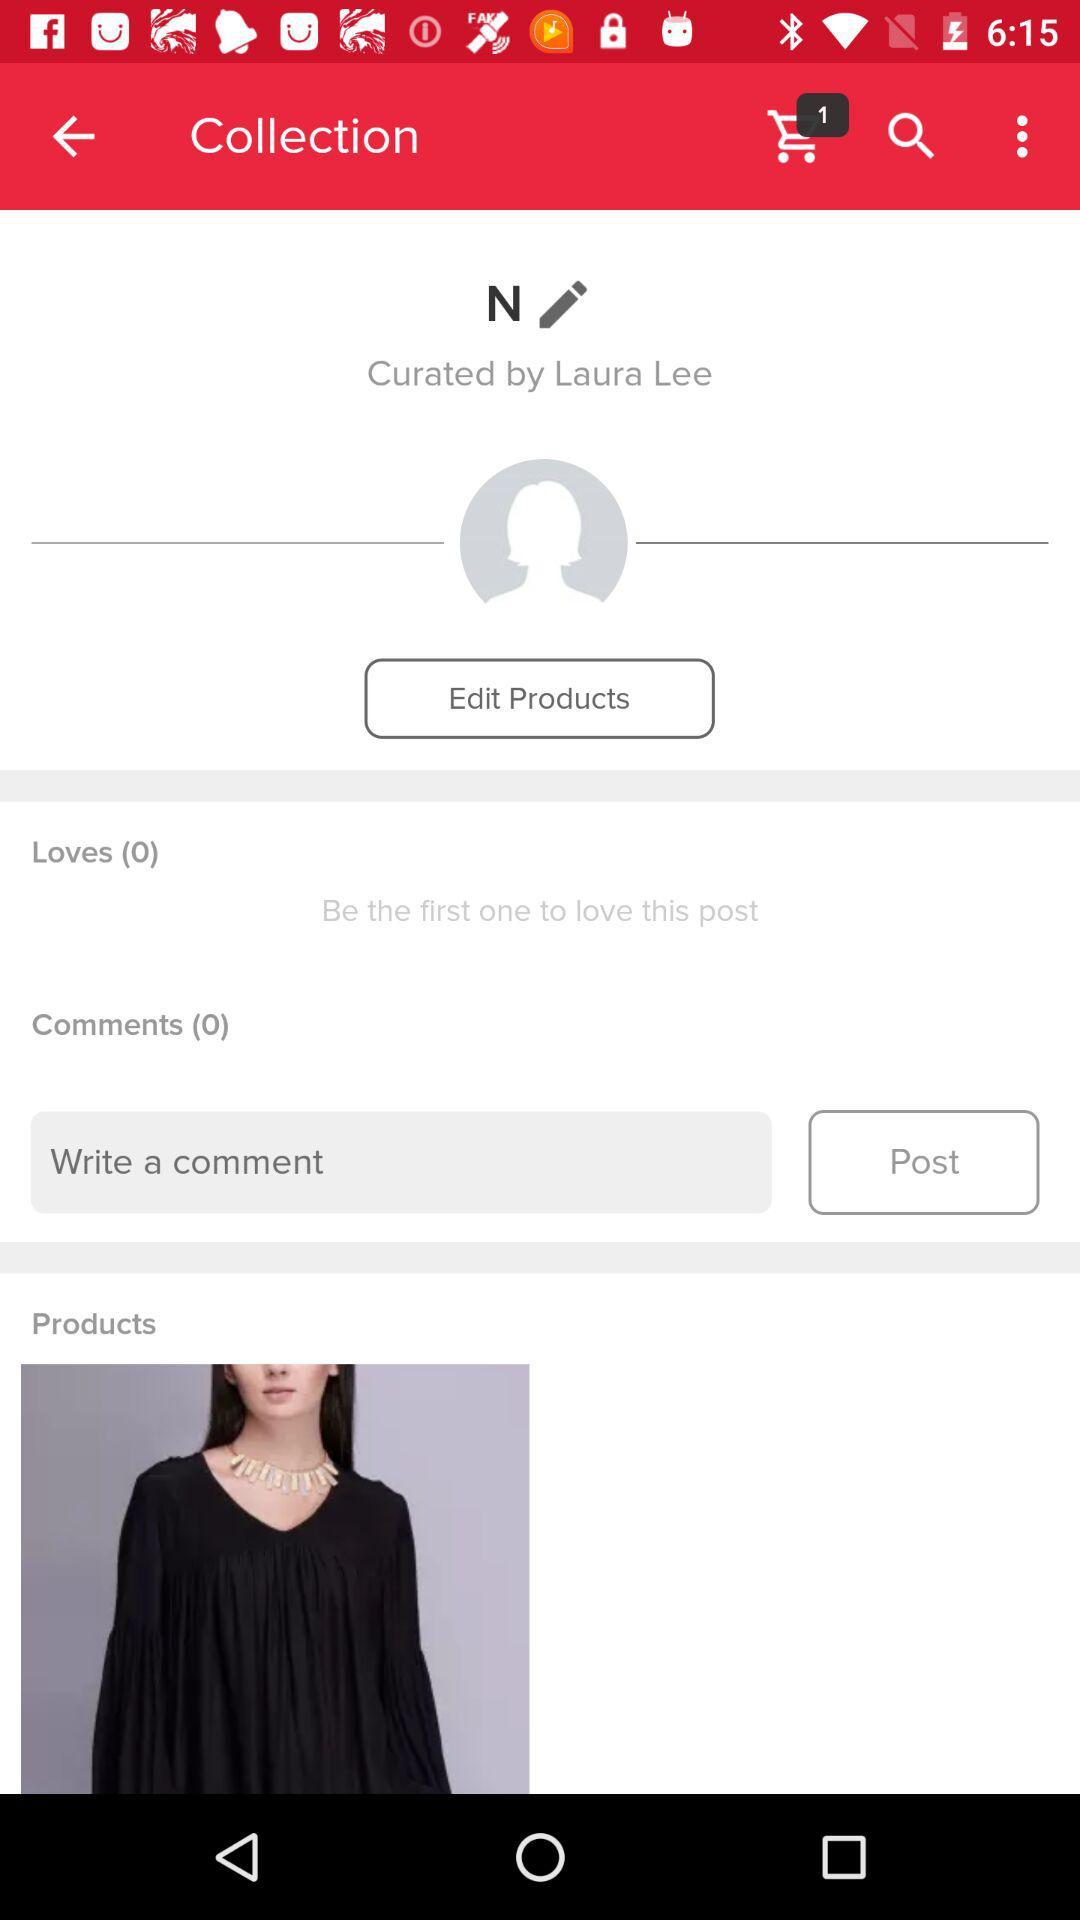Is there any comment?
When the provided information is insufficient, respond with <no answer>. <no answer> 